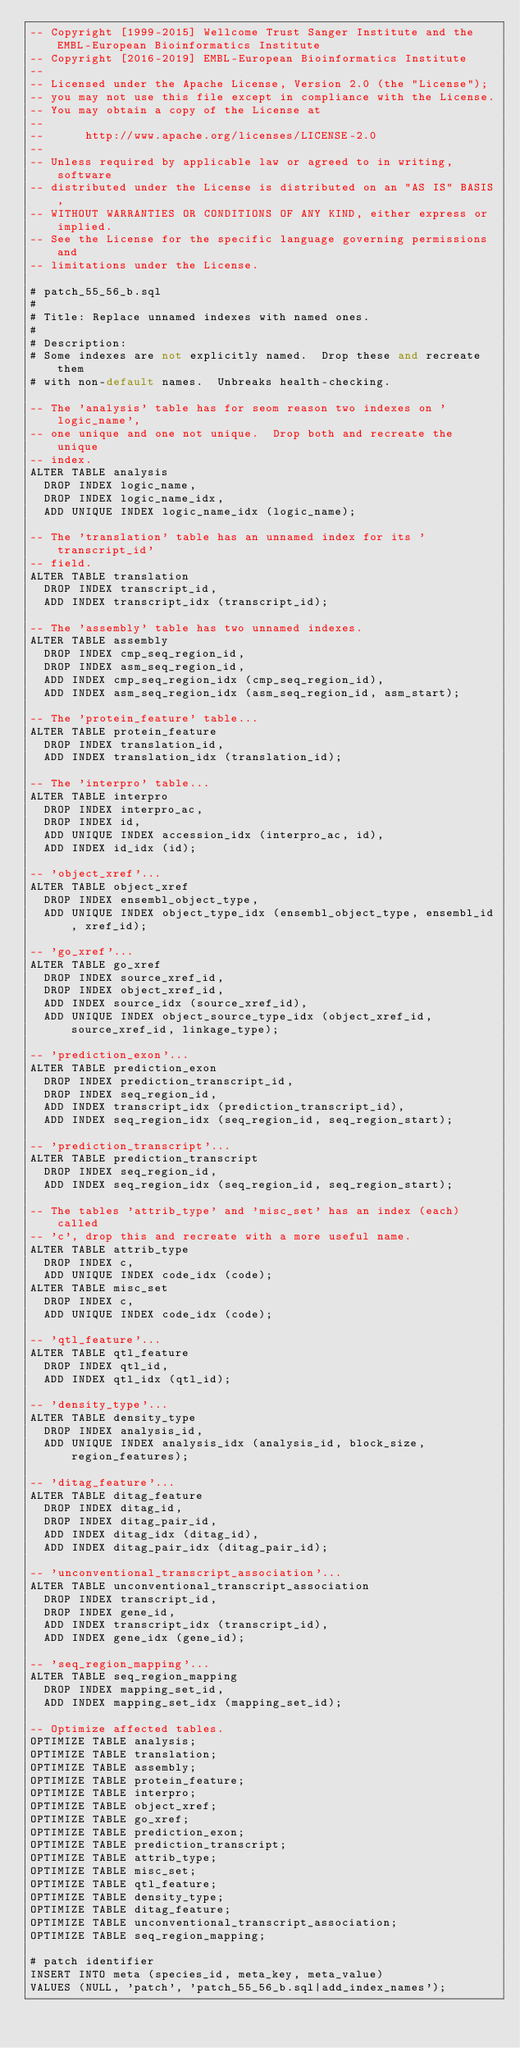Convert code to text. <code><loc_0><loc_0><loc_500><loc_500><_SQL_>-- Copyright [1999-2015] Wellcome Trust Sanger Institute and the EMBL-European Bioinformatics Institute
-- Copyright [2016-2019] EMBL-European Bioinformatics Institute
-- 
-- Licensed under the Apache License, Version 2.0 (the "License");
-- you may not use this file except in compliance with the License.
-- You may obtain a copy of the License at
-- 
--      http://www.apache.org/licenses/LICENSE-2.0
-- 
-- Unless required by applicable law or agreed to in writing, software
-- distributed under the License is distributed on an "AS IS" BASIS,
-- WITHOUT WARRANTIES OR CONDITIONS OF ANY KIND, either express or implied.
-- See the License for the specific language governing permissions and
-- limitations under the License.

# patch_55_56_b.sql
#
# Title: Replace unnamed indexes with named ones.
#
# Description:
# Some indexes are not explicitly named.  Drop these and recreate them
# with non-default names.  Unbreaks health-checking.

-- The 'analysis' table has for seom reason two indexes on 'logic_name',
-- one unique and one not unique.  Drop both and recreate the unique
-- index.
ALTER TABLE analysis
  DROP INDEX logic_name,
  DROP INDEX logic_name_idx,
  ADD UNIQUE INDEX logic_name_idx (logic_name);

-- The 'translation' table has an unnamed index for its 'transcript_id'
-- field.
ALTER TABLE translation
  DROP INDEX transcript_id,
  ADD INDEX transcript_idx (transcript_id);

-- The 'assembly' table has two unnamed indexes.
ALTER TABLE assembly
  DROP INDEX cmp_seq_region_id,
  DROP INDEX asm_seq_region_id,
  ADD INDEX cmp_seq_region_idx (cmp_seq_region_id),
  ADD INDEX asm_seq_region_idx (asm_seq_region_id, asm_start);

-- The 'protein_feature' table...
ALTER TABLE protein_feature
  DROP INDEX translation_id,
  ADD INDEX translation_idx (translation_id);

-- The 'interpro' table...
ALTER TABLE interpro
  DROP INDEX interpro_ac,
  DROP INDEX id,
  ADD UNIQUE INDEX accession_idx (interpro_ac, id),
  ADD INDEX id_idx (id);

-- 'object_xref'...
ALTER TABLE object_xref
  DROP INDEX ensembl_object_type,
  ADD UNIQUE INDEX object_type_idx (ensembl_object_type, ensembl_id, xref_id);

-- 'go_xref'...
ALTER TABLE go_xref
  DROP INDEX source_xref_id,
  DROP INDEX object_xref_id,
  ADD INDEX source_idx (source_xref_id),
  ADD UNIQUE INDEX object_source_type_idx (object_xref_id, source_xref_id, linkage_type);

-- 'prediction_exon'...
ALTER TABLE prediction_exon
  DROP INDEX prediction_transcript_id,
  DROP INDEX seq_region_id,
  ADD INDEX transcript_idx (prediction_transcript_id),
  ADD INDEX seq_region_idx (seq_region_id, seq_region_start);

-- 'prediction_transcript'...
ALTER TABLE prediction_transcript
  DROP INDEX seq_region_id,
  ADD INDEX seq_region_idx (seq_region_id, seq_region_start);

-- The tables 'attrib_type' and 'misc_set' has an index (each) called
-- 'c', drop this and recreate with a more useful name.
ALTER TABLE attrib_type
  DROP INDEX c,
  ADD UNIQUE INDEX code_idx (code);
ALTER TABLE misc_set
  DROP INDEX c,
  ADD UNIQUE INDEX code_idx (code);

-- 'qtl_feature'...
ALTER TABLE qtl_feature
  DROP INDEX qtl_id,
  ADD INDEX qtl_idx (qtl_id);

-- 'density_type'...
ALTER TABLE density_type
  DROP INDEX analysis_id,
  ADD UNIQUE INDEX analysis_idx (analysis_id, block_size, region_features);

-- 'ditag_feature'...
ALTER TABLE ditag_feature
  DROP INDEX ditag_id,
  DROP INDEX ditag_pair_id,
  ADD INDEX ditag_idx (ditag_id),
  ADD INDEX ditag_pair_idx (ditag_pair_id);

-- 'unconventional_transcript_association'...
ALTER TABLE unconventional_transcript_association
  DROP INDEX transcript_id,
  DROP INDEX gene_id,
  ADD INDEX transcript_idx (transcript_id),
  ADD INDEX gene_idx (gene_id);

-- 'seq_region_mapping'...
ALTER TABLE seq_region_mapping
  DROP INDEX mapping_set_id,
  ADD INDEX mapping_set_idx (mapping_set_id);

-- Optimize affected tables.
OPTIMIZE TABLE analysis;
OPTIMIZE TABLE translation;
OPTIMIZE TABLE assembly;
OPTIMIZE TABLE protein_feature;
OPTIMIZE TABLE interpro;
OPTIMIZE TABLE object_xref;
OPTIMIZE TABLE go_xref;
OPTIMIZE TABLE prediction_exon;
OPTIMIZE TABLE prediction_transcript;
OPTIMIZE TABLE attrib_type;
OPTIMIZE TABLE misc_set;
OPTIMIZE TABLE qtl_feature;
OPTIMIZE TABLE density_type;
OPTIMIZE TABLE ditag_feature;
OPTIMIZE TABLE unconventional_transcript_association;
OPTIMIZE TABLE seq_region_mapping;

# patch identifier
INSERT INTO meta (species_id, meta_key, meta_value)
VALUES (NULL, 'patch', 'patch_55_56_b.sql|add_index_names');
</code> 